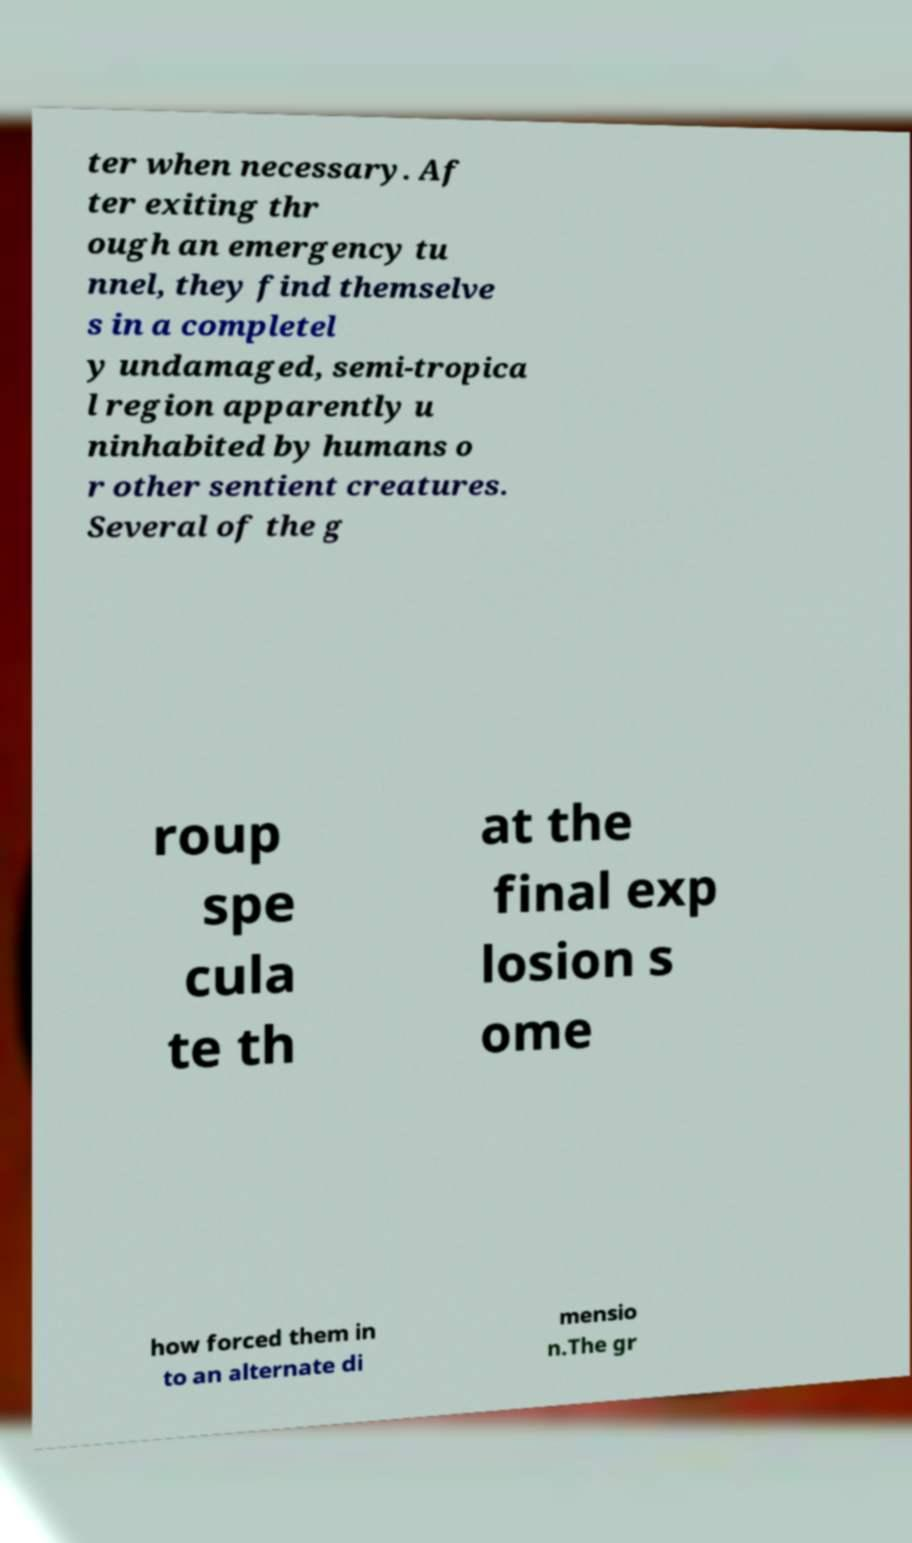Can you read and provide the text displayed in the image?This photo seems to have some interesting text. Can you extract and type it out for me? ter when necessary. Af ter exiting thr ough an emergency tu nnel, they find themselve s in a completel y undamaged, semi-tropica l region apparently u ninhabited by humans o r other sentient creatures. Several of the g roup spe cula te th at the final exp losion s ome how forced them in to an alternate di mensio n.The gr 